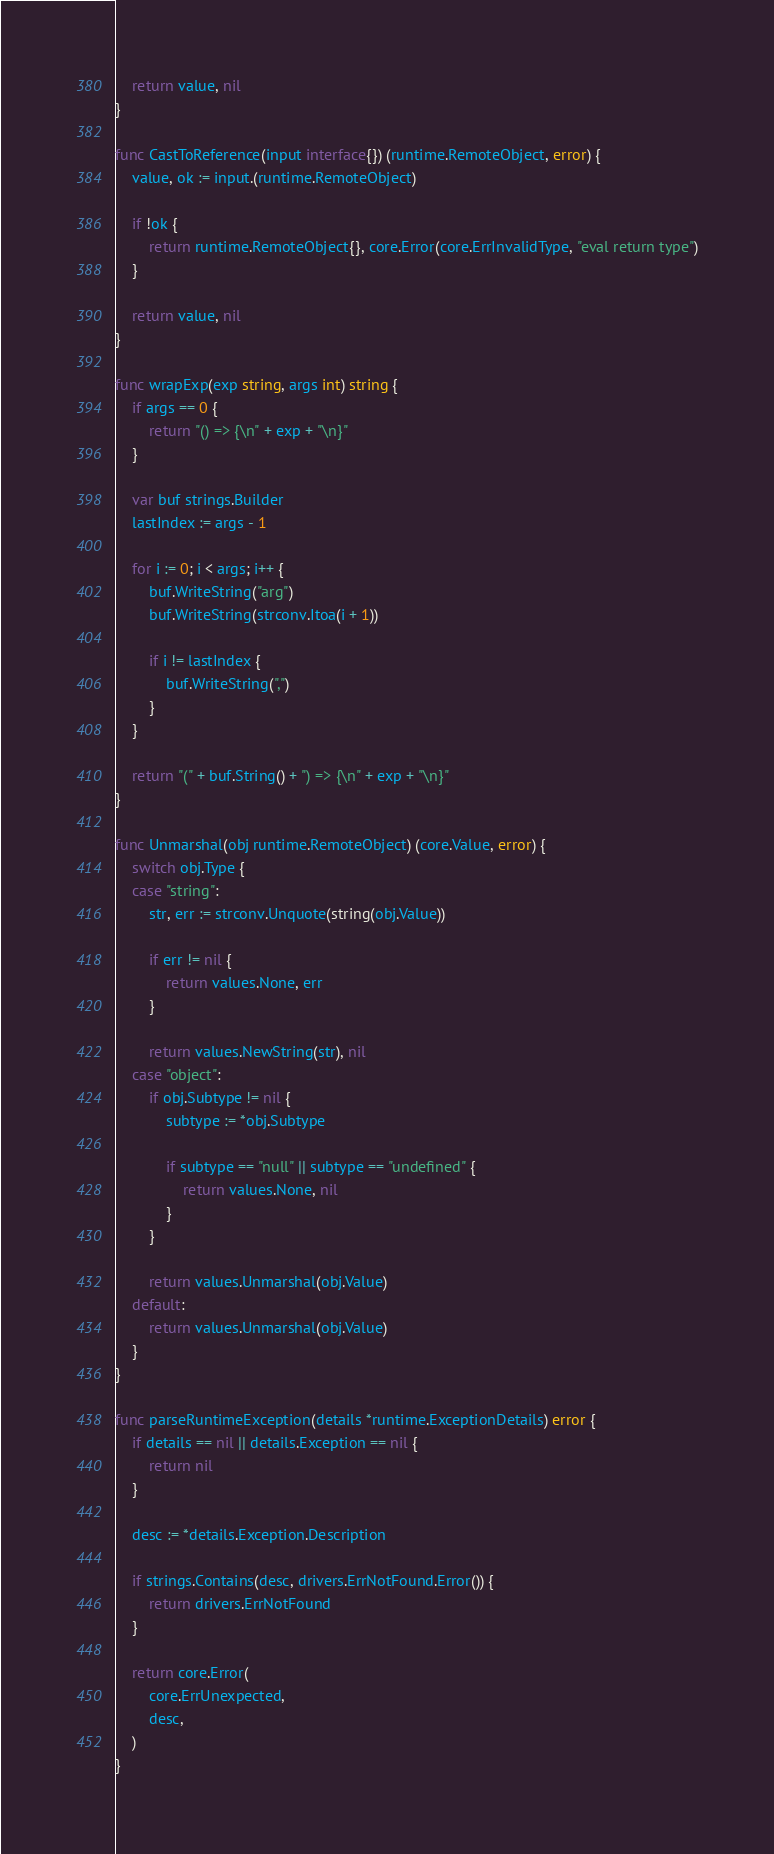Convert code to text. <code><loc_0><loc_0><loc_500><loc_500><_Go_>
	return value, nil
}

func CastToReference(input interface{}) (runtime.RemoteObject, error) {
	value, ok := input.(runtime.RemoteObject)

	if !ok {
		return runtime.RemoteObject{}, core.Error(core.ErrInvalidType, "eval return type")
	}

	return value, nil
}

func wrapExp(exp string, args int) string {
	if args == 0 {
		return "() => {\n" + exp + "\n}"
	}

	var buf strings.Builder
	lastIndex := args - 1

	for i := 0; i < args; i++ {
		buf.WriteString("arg")
		buf.WriteString(strconv.Itoa(i + 1))

		if i != lastIndex {
			buf.WriteString(",")
		}
	}

	return "(" + buf.String() + ") => {\n" + exp + "\n}"
}

func Unmarshal(obj runtime.RemoteObject) (core.Value, error) {
	switch obj.Type {
	case "string":
		str, err := strconv.Unquote(string(obj.Value))

		if err != nil {
			return values.None, err
		}

		return values.NewString(str), nil
	case "object":
		if obj.Subtype != nil {
			subtype := *obj.Subtype

			if subtype == "null" || subtype == "undefined" {
				return values.None, nil
			}
		}

		return values.Unmarshal(obj.Value)
	default:
		return values.Unmarshal(obj.Value)
	}
}

func parseRuntimeException(details *runtime.ExceptionDetails) error {
	if details == nil || details.Exception == nil {
		return nil
	}

	desc := *details.Exception.Description

	if strings.Contains(desc, drivers.ErrNotFound.Error()) {
		return drivers.ErrNotFound
	}

	return core.Error(
		core.ErrUnexpected,
		desc,
	)
}
</code> 